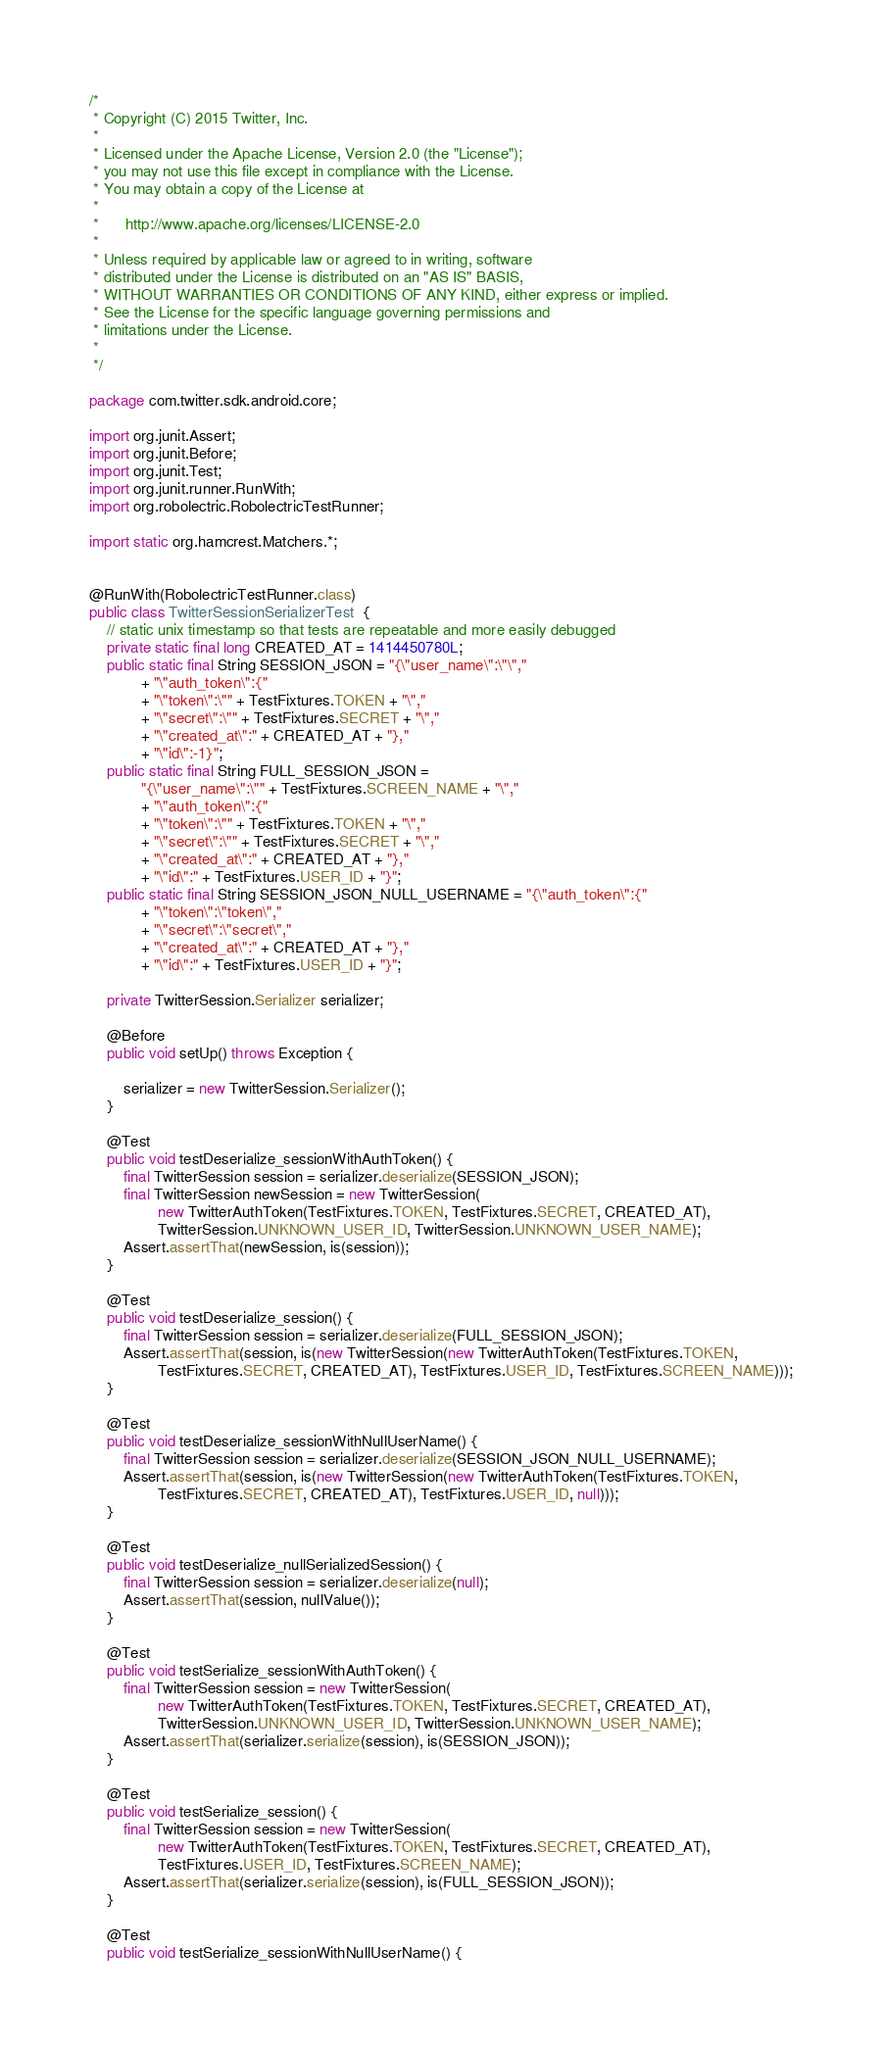<code> <loc_0><loc_0><loc_500><loc_500><_Java_>/*
 * Copyright (C) 2015 Twitter, Inc.
 *
 * Licensed under the Apache License, Version 2.0 (the "License");
 * you may not use this file except in compliance with the License.
 * You may obtain a copy of the License at
 *
 *      http://www.apache.org/licenses/LICENSE-2.0
 *
 * Unless required by applicable law or agreed to in writing, software
 * distributed under the License is distributed on an "AS IS" BASIS,
 * WITHOUT WARRANTIES OR CONDITIONS OF ANY KIND, either express or implied.
 * See the License for the specific language governing permissions and
 * limitations under the License.
 *
 */

package com.twitter.sdk.android.core;

import org.junit.Assert;
import org.junit.Before;
import org.junit.Test;
import org.junit.runner.RunWith;
import org.robolectric.RobolectricTestRunner;

import static org.hamcrest.Matchers.*;


@RunWith(RobolectricTestRunner.class)
public class TwitterSessionSerializerTest  {
    // static unix timestamp so that tests are repeatable and more easily debugged
    private static final long CREATED_AT = 1414450780L;
    public static final String SESSION_JSON = "{\"user_name\":\"\","
            + "\"auth_token\":{"
            + "\"token\":\"" + TestFixtures.TOKEN + "\","
            + "\"secret\":\"" + TestFixtures.SECRET + "\","
            + "\"created_at\":" + CREATED_AT + "},"
            + "\"id\":-1}";
    public static final String FULL_SESSION_JSON =
            "{\"user_name\":\"" + TestFixtures.SCREEN_NAME + "\","
            + "\"auth_token\":{"
            + "\"token\":\"" + TestFixtures.TOKEN + "\","
            + "\"secret\":\"" + TestFixtures.SECRET + "\","
            + "\"created_at\":" + CREATED_AT + "},"
            + "\"id\":" + TestFixtures.USER_ID + "}";
    public static final String SESSION_JSON_NULL_USERNAME = "{\"auth_token\":{"
            + "\"token\":\"token\","
            + "\"secret\":\"secret\","
            + "\"created_at\":" + CREATED_AT + "},"
            + "\"id\":" + TestFixtures.USER_ID + "}";

    private TwitterSession.Serializer serializer;

    @Before
    public void setUp() throws Exception {

        serializer = new TwitterSession.Serializer();
    }

    @Test
    public void testDeserialize_sessionWithAuthToken() {
        final TwitterSession session = serializer.deserialize(SESSION_JSON);
        final TwitterSession newSession = new TwitterSession(
                new TwitterAuthToken(TestFixtures.TOKEN, TestFixtures.SECRET, CREATED_AT),
                TwitterSession.UNKNOWN_USER_ID, TwitterSession.UNKNOWN_USER_NAME);
        Assert.assertThat(newSession, is(session));
    }

    @Test
    public void testDeserialize_session() {
        final TwitterSession session = serializer.deserialize(FULL_SESSION_JSON);
        Assert.assertThat(session, is(new TwitterSession(new TwitterAuthToken(TestFixtures.TOKEN,
                TestFixtures.SECRET, CREATED_AT), TestFixtures.USER_ID, TestFixtures.SCREEN_NAME)));
    }

    @Test
    public void testDeserialize_sessionWithNullUserName() {
        final TwitterSession session = serializer.deserialize(SESSION_JSON_NULL_USERNAME);
        Assert.assertThat(session, is(new TwitterSession(new TwitterAuthToken(TestFixtures.TOKEN,
                TestFixtures.SECRET, CREATED_AT), TestFixtures.USER_ID, null)));
    }

    @Test
    public void testDeserialize_nullSerializedSession() {
        final TwitterSession session = serializer.deserialize(null);
        Assert.assertThat(session, nullValue());
    }

    @Test
    public void testSerialize_sessionWithAuthToken() {
        final TwitterSession session = new TwitterSession(
                new TwitterAuthToken(TestFixtures.TOKEN, TestFixtures.SECRET, CREATED_AT),
                TwitterSession.UNKNOWN_USER_ID, TwitterSession.UNKNOWN_USER_NAME);
        Assert.assertThat(serializer.serialize(session), is(SESSION_JSON));
    }

    @Test
    public void testSerialize_session() {
        final TwitterSession session = new TwitterSession(
                new TwitterAuthToken(TestFixtures.TOKEN, TestFixtures.SECRET, CREATED_AT),
                TestFixtures.USER_ID, TestFixtures.SCREEN_NAME);
        Assert.assertThat(serializer.serialize(session), is(FULL_SESSION_JSON));
    }

    @Test
    public void testSerialize_sessionWithNullUserName() {</code> 